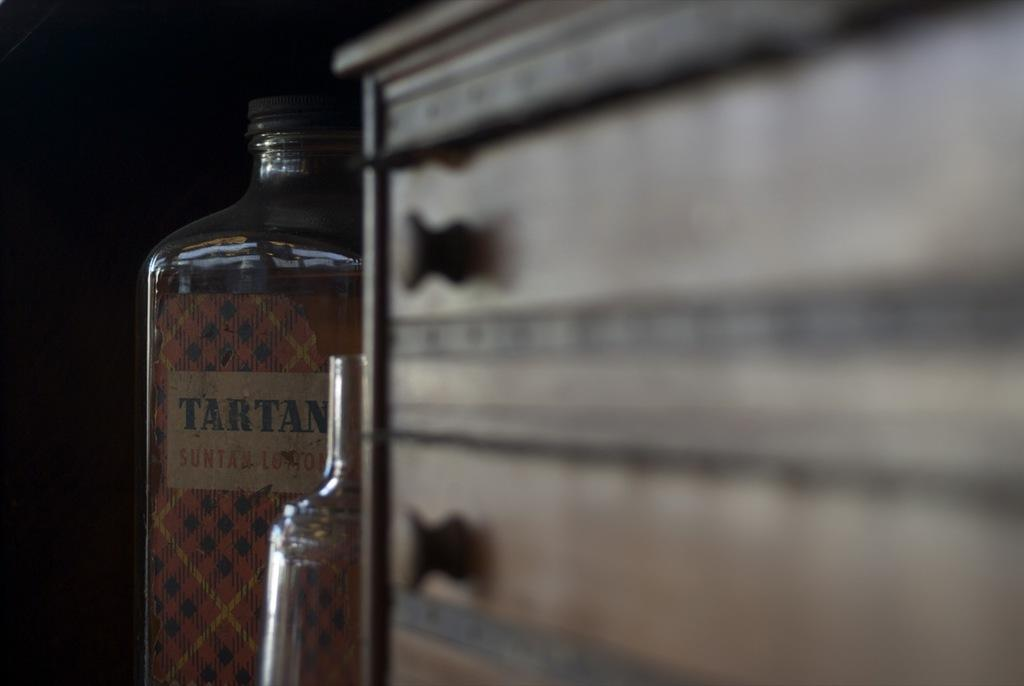What is the main subject in the image? There is an object in the image. What else can be seen in the image besides the main subject? There are bottles in the image. Can you describe the background of the image? The background of the image is dark. How many ants are crawling on the knee in the image? There are no ants or knees present in the image. 